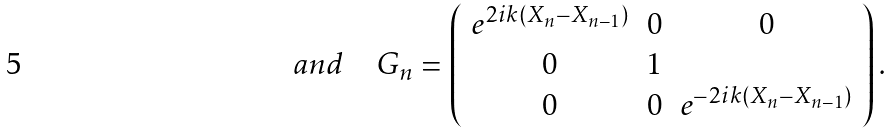<formula> <loc_0><loc_0><loc_500><loc_500>a n d \quad G _ { n } = \left ( \begin{array} { c c c } e ^ { 2 i k ( X _ { n } - X _ { n - 1 } ) } & 0 & 0 \\ 0 & 1 & \\ 0 & 0 & e ^ { - 2 i k ( X _ { n } - X _ { n - 1 } ) } \end{array} \right ) .</formula> 